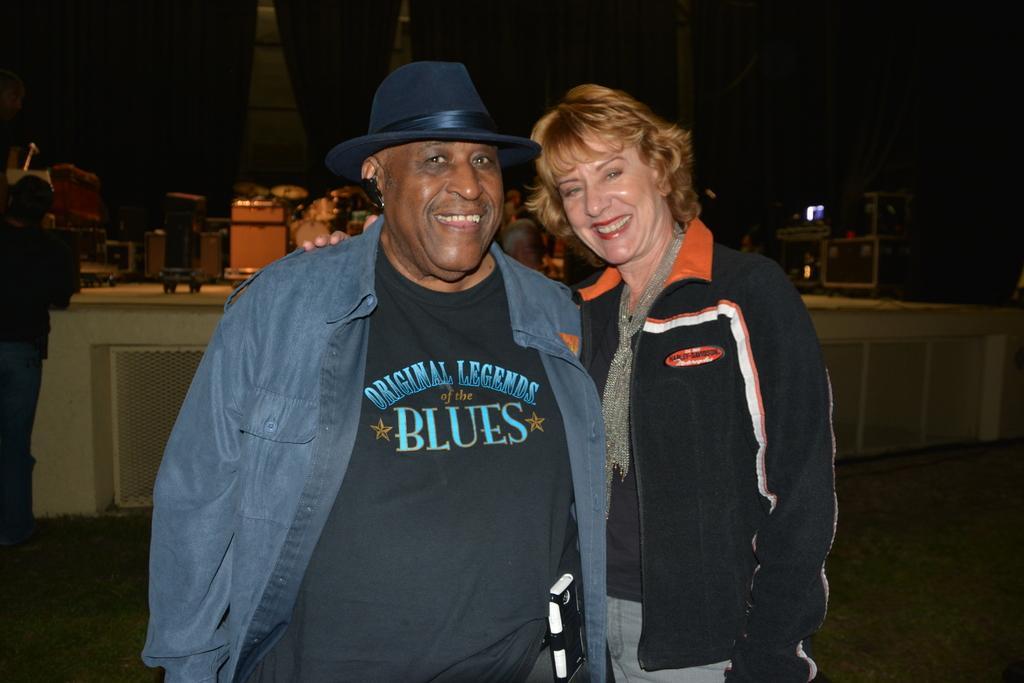Could you give a brief overview of what you see in this image? There is a person in gray color jacket standing and smiling near a woman who is smiling and keeping hand on the shoulder of that person and standing. In the background, there is a person standing near a stage on which, there are some objects. In the background, there is a building. And the background is dark in color. 